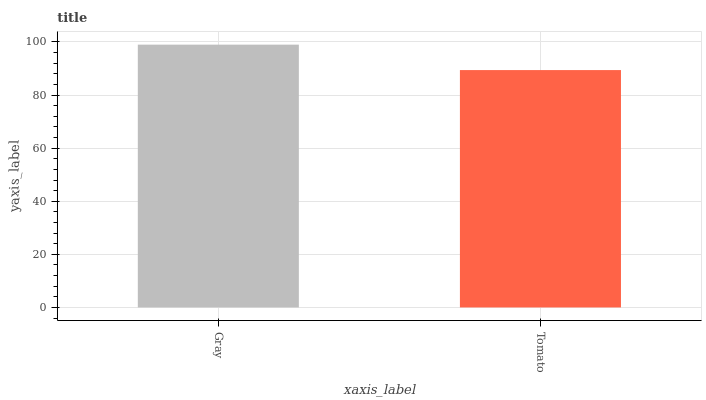Is Tomato the minimum?
Answer yes or no. Yes. Is Gray the maximum?
Answer yes or no. Yes. Is Tomato the maximum?
Answer yes or no. No. Is Gray greater than Tomato?
Answer yes or no. Yes. Is Tomato less than Gray?
Answer yes or no. Yes. Is Tomato greater than Gray?
Answer yes or no. No. Is Gray less than Tomato?
Answer yes or no. No. Is Gray the high median?
Answer yes or no. Yes. Is Tomato the low median?
Answer yes or no. Yes. Is Tomato the high median?
Answer yes or no. No. Is Gray the low median?
Answer yes or no. No. 